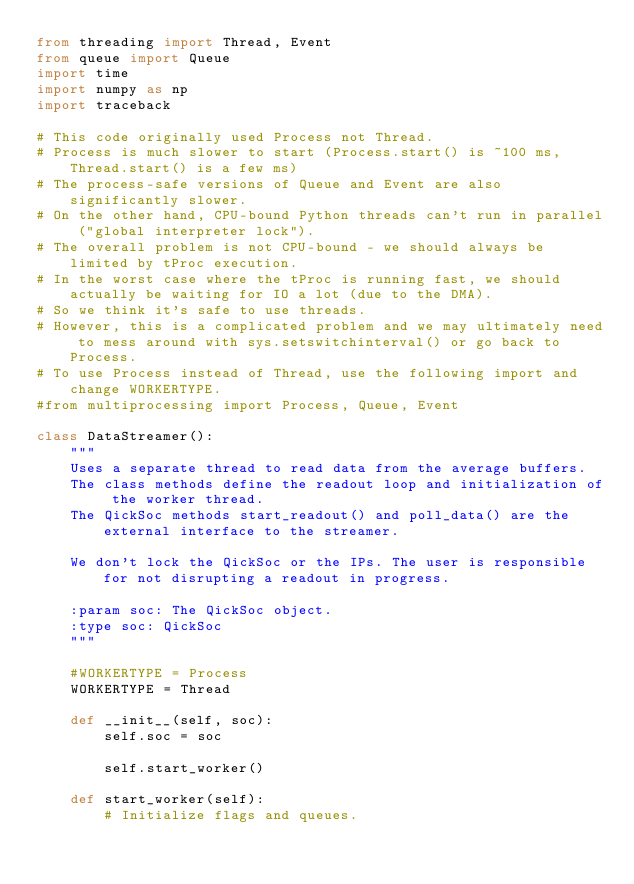<code> <loc_0><loc_0><loc_500><loc_500><_Python_>from threading import Thread, Event
from queue import Queue
import time
import numpy as np
import traceback

# This code originally used Process not Thread.
# Process is much slower to start (Process.start() is ~100 ms, Thread.start() is a few ms)
# The process-safe versions of Queue and Event are also significantly slower.
# On the other hand, CPU-bound Python threads can't run in parallel ("global interpreter lock").
# The overall problem is not CPU-bound - we should always be limited by tProc execution.
# In the worst case where the tProc is running fast, we should actually be waiting for IO a lot (due to the DMA).
# So we think it's safe to use threads.
# However, this is a complicated problem and we may ultimately need to mess around with sys.setswitchinterval() or go back to Process.
# To use Process instead of Thread, use the following import and change WORKERTYPE.
#from multiprocessing import Process, Queue, Event

class DataStreamer():
    """
    Uses a separate thread to read data from the average buffers.
    The class methods define the readout loop and initialization of the worker thread.
    The QickSoc methods start_readout() and poll_data() are the external interface to the streamer.

    We don't lock the QickSoc or the IPs. The user is responsible for not disrupting a readout in progress.

    :param soc: The QickSoc object.
    :type soc: QickSoc
    """

    #WORKERTYPE = Process
    WORKERTYPE = Thread

    def __init__(self, soc):
        self.soc = soc

        self.start_worker()

    def start_worker(self):
        # Initialize flags and queues.</code> 